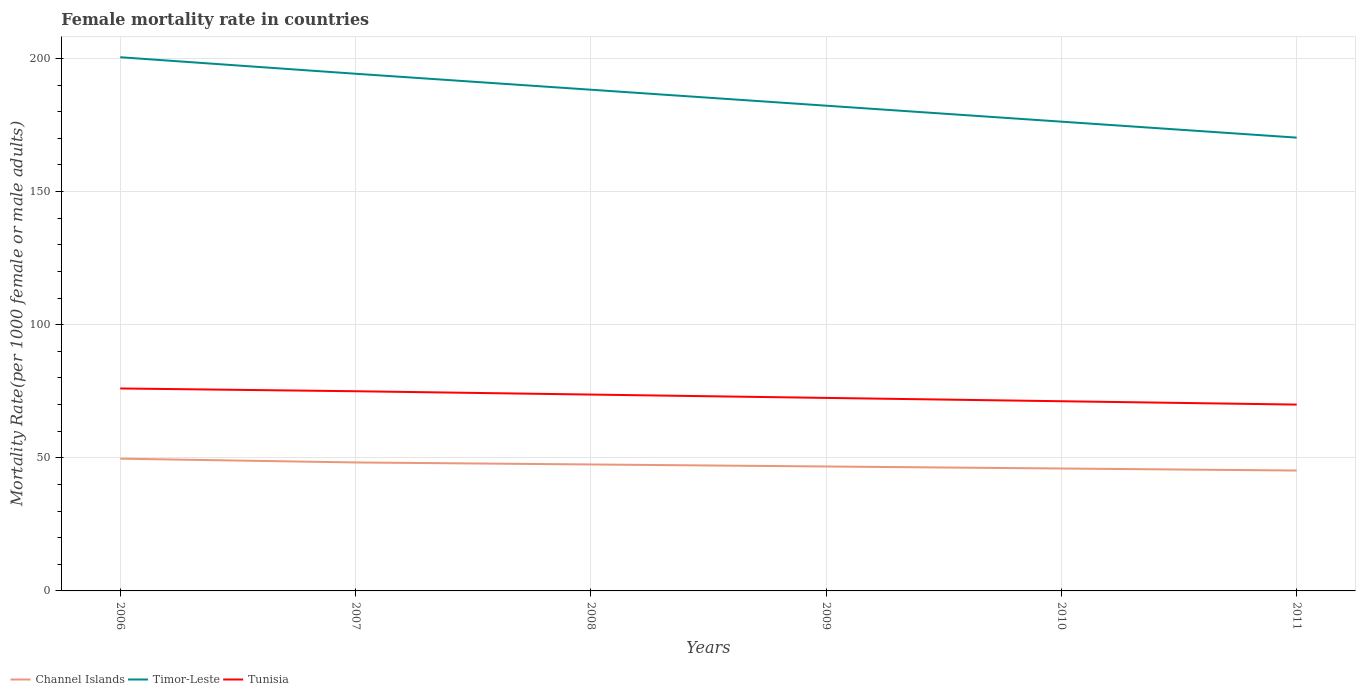Does the line corresponding to Channel Islands intersect with the line corresponding to Timor-Leste?
Give a very brief answer. No. Is the number of lines equal to the number of legend labels?
Offer a terse response. Yes. Across all years, what is the maximum female mortality rate in Tunisia?
Your response must be concise. 70. What is the total female mortality rate in Timor-Leste in the graph?
Give a very brief answer. 12. What is the difference between the highest and the second highest female mortality rate in Channel Islands?
Give a very brief answer. 4.45. What is the difference between the highest and the lowest female mortality rate in Tunisia?
Your answer should be compact. 3. Is the female mortality rate in Channel Islands strictly greater than the female mortality rate in Timor-Leste over the years?
Ensure brevity in your answer.  Yes. How many lines are there?
Give a very brief answer. 3. Does the graph contain any zero values?
Your response must be concise. No. Does the graph contain grids?
Your answer should be compact. Yes. Where does the legend appear in the graph?
Your response must be concise. Bottom left. How are the legend labels stacked?
Offer a terse response. Horizontal. What is the title of the graph?
Give a very brief answer. Female mortality rate in countries. Does "Bahamas" appear as one of the legend labels in the graph?
Give a very brief answer. No. What is the label or title of the X-axis?
Offer a very short reply. Years. What is the label or title of the Y-axis?
Provide a short and direct response. Mortality Rate(per 1000 female or male adults). What is the Mortality Rate(per 1000 female or male adults) of Channel Islands in 2006?
Offer a very short reply. 49.68. What is the Mortality Rate(per 1000 female or male adults) in Timor-Leste in 2006?
Ensure brevity in your answer.  200.48. What is the Mortality Rate(per 1000 female or male adults) of Tunisia in 2006?
Make the answer very short. 76.05. What is the Mortality Rate(per 1000 female or male adults) in Channel Islands in 2007?
Provide a short and direct response. 48.26. What is the Mortality Rate(per 1000 female or male adults) of Timor-Leste in 2007?
Keep it short and to the point. 194.28. What is the Mortality Rate(per 1000 female or male adults) of Tunisia in 2007?
Provide a succinct answer. 75.02. What is the Mortality Rate(per 1000 female or male adults) of Channel Islands in 2008?
Your answer should be compact. 47.5. What is the Mortality Rate(per 1000 female or male adults) in Timor-Leste in 2008?
Keep it short and to the point. 188.28. What is the Mortality Rate(per 1000 female or male adults) of Tunisia in 2008?
Ensure brevity in your answer.  73.76. What is the Mortality Rate(per 1000 female or male adults) in Channel Islands in 2009?
Provide a succinct answer. 46.74. What is the Mortality Rate(per 1000 female or male adults) in Timor-Leste in 2009?
Ensure brevity in your answer.  182.28. What is the Mortality Rate(per 1000 female or male adults) of Tunisia in 2009?
Provide a succinct answer. 72.51. What is the Mortality Rate(per 1000 female or male adults) of Channel Islands in 2010?
Provide a succinct answer. 45.98. What is the Mortality Rate(per 1000 female or male adults) in Timor-Leste in 2010?
Give a very brief answer. 176.28. What is the Mortality Rate(per 1000 female or male adults) in Tunisia in 2010?
Offer a terse response. 71.25. What is the Mortality Rate(per 1000 female or male adults) of Channel Islands in 2011?
Your response must be concise. 45.23. What is the Mortality Rate(per 1000 female or male adults) in Timor-Leste in 2011?
Your answer should be compact. 170.28. What is the Mortality Rate(per 1000 female or male adults) in Tunisia in 2011?
Provide a succinct answer. 70. Across all years, what is the maximum Mortality Rate(per 1000 female or male adults) in Channel Islands?
Offer a terse response. 49.68. Across all years, what is the maximum Mortality Rate(per 1000 female or male adults) in Timor-Leste?
Offer a very short reply. 200.48. Across all years, what is the maximum Mortality Rate(per 1000 female or male adults) of Tunisia?
Provide a short and direct response. 76.05. Across all years, what is the minimum Mortality Rate(per 1000 female or male adults) in Channel Islands?
Give a very brief answer. 45.23. Across all years, what is the minimum Mortality Rate(per 1000 female or male adults) in Timor-Leste?
Ensure brevity in your answer.  170.28. Across all years, what is the minimum Mortality Rate(per 1000 female or male adults) in Tunisia?
Your answer should be compact. 70. What is the total Mortality Rate(per 1000 female or male adults) in Channel Islands in the graph?
Ensure brevity in your answer.  283.4. What is the total Mortality Rate(per 1000 female or male adults) in Timor-Leste in the graph?
Your response must be concise. 1111.89. What is the total Mortality Rate(per 1000 female or male adults) of Tunisia in the graph?
Your answer should be compact. 438.59. What is the difference between the Mortality Rate(per 1000 female or male adults) in Channel Islands in 2006 and that in 2007?
Provide a short and direct response. 1.42. What is the difference between the Mortality Rate(per 1000 female or male adults) of Timor-Leste in 2006 and that in 2007?
Give a very brief answer. 6.2. What is the difference between the Mortality Rate(per 1000 female or male adults) of Tunisia in 2006 and that in 2007?
Keep it short and to the point. 1.03. What is the difference between the Mortality Rate(per 1000 female or male adults) in Channel Islands in 2006 and that in 2008?
Your answer should be very brief. 2.18. What is the difference between the Mortality Rate(per 1000 female or male adults) of Timor-Leste in 2006 and that in 2008?
Your answer should be very brief. 12.2. What is the difference between the Mortality Rate(per 1000 female or male adults) of Tunisia in 2006 and that in 2008?
Your response must be concise. 2.29. What is the difference between the Mortality Rate(per 1000 female or male adults) of Channel Islands in 2006 and that in 2009?
Keep it short and to the point. 2.94. What is the difference between the Mortality Rate(per 1000 female or male adults) of Timor-Leste in 2006 and that in 2009?
Provide a short and direct response. 18.2. What is the difference between the Mortality Rate(per 1000 female or male adults) of Tunisia in 2006 and that in 2009?
Ensure brevity in your answer.  3.54. What is the difference between the Mortality Rate(per 1000 female or male adults) of Channel Islands in 2006 and that in 2010?
Provide a short and direct response. 3.69. What is the difference between the Mortality Rate(per 1000 female or male adults) in Timor-Leste in 2006 and that in 2010?
Your answer should be compact. 24.2. What is the difference between the Mortality Rate(per 1000 female or male adults) in Tunisia in 2006 and that in 2010?
Offer a very short reply. 4.79. What is the difference between the Mortality Rate(per 1000 female or male adults) of Channel Islands in 2006 and that in 2011?
Provide a short and direct response. 4.45. What is the difference between the Mortality Rate(per 1000 female or male adults) of Timor-Leste in 2006 and that in 2011?
Your answer should be very brief. 30.2. What is the difference between the Mortality Rate(per 1000 female or male adults) of Tunisia in 2006 and that in 2011?
Your answer should be very brief. 6.05. What is the difference between the Mortality Rate(per 1000 female or male adults) of Channel Islands in 2007 and that in 2008?
Provide a succinct answer. 0.76. What is the difference between the Mortality Rate(per 1000 female or male adults) of Timor-Leste in 2007 and that in 2008?
Make the answer very short. 6. What is the difference between the Mortality Rate(per 1000 female or male adults) in Tunisia in 2007 and that in 2008?
Keep it short and to the point. 1.25. What is the difference between the Mortality Rate(per 1000 female or male adults) in Channel Islands in 2007 and that in 2009?
Your response must be concise. 1.52. What is the difference between the Mortality Rate(per 1000 female or male adults) in Timor-Leste in 2007 and that in 2009?
Make the answer very short. 12. What is the difference between the Mortality Rate(per 1000 female or male adults) of Tunisia in 2007 and that in 2009?
Give a very brief answer. 2.51. What is the difference between the Mortality Rate(per 1000 female or male adults) in Channel Islands in 2007 and that in 2010?
Your response must be concise. 2.28. What is the difference between the Mortality Rate(per 1000 female or male adults) of Timor-Leste in 2007 and that in 2010?
Your answer should be compact. 18. What is the difference between the Mortality Rate(per 1000 female or male adults) in Tunisia in 2007 and that in 2010?
Your answer should be compact. 3.76. What is the difference between the Mortality Rate(per 1000 female or male adults) of Channel Islands in 2007 and that in 2011?
Give a very brief answer. 3.04. What is the difference between the Mortality Rate(per 1000 female or male adults) in Timor-Leste in 2007 and that in 2011?
Offer a terse response. 24. What is the difference between the Mortality Rate(per 1000 female or male adults) of Tunisia in 2007 and that in 2011?
Provide a short and direct response. 5.01. What is the difference between the Mortality Rate(per 1000 female or male adults) of Channel Islands in 2008 and that in 2009?
Your answer should be very brief. 0.76. What is the difference between the Mortality Rate(per 1000 female or male adults) in Timor-Leste in 2008 and that in 2009?
Your answer should be very brief. 6. What is the difference between the Mortality Rate(per 1000 female or male adults) in Tunisia in 2008 and that in 2009?
Your answer should be very brief. 1.25. What is the difference between the Mortality Rate(per 1000 female or male adults) in Channel Islands in 2008 and that in 2010?
Your response must be concise. 1.52. What is the difference between the Mortality Rate(per 1000 female or male adults) of Timor-Leste in 2008 and that in 2010?
Give a very brief answer. 12. What is the difference between the Mortality Rate(per 1000 female or male adults) in Tunisia in 2008 and that in 2010?
Offer a very short reply. 2.51. What is the difference between the Mortality Rate(per 1000 female or male adults) of Channel Islands in 2008 and that in 2011?
Your answer should be compact. 2.28. What is the difference between the Mortality Rate(per 1000 female or male adults) of Timor-Leste in 2008 and that in 2011?
Provide a succinct answer. 18. What is the difference between the Mortality Rate(per 1000 female or male adults) in Tunisia in 2008 and that in 2011?
Make the answer very short. 3.76. What is the difference between the Mortality Rate(per 1000 female or male adults) of Channel Islands in 2009 and that in 2010?
Keep it short and to the point. 0.76. What is the difference between the Mortality Rate(per 1000 female or male adults) in Timor-Leste in 2009 and that in 2010?
Provide a succinct answer. 6. What is the difference between the Mortality Rate(per 1000 female or male adults) in Tunisia in 2009 and that in 2010?
Make the answer very short. 1.25. What is the difference between the Mortality Rate(per 1000 female or male adults) of Channel Islands in 2009 and that in 2011?
Offer a terse response. 1.52. What is the difference between the Mortality Rate(per 1000 female or male adults) in Timor-Leste in 2009 and that in 2011?
Your response must be concise. 12. What is the difference between the Mortality Rate(per 1000 female or male adults) in Tunisia in 2009 and that in 2011?
Your response must be concise. 2.51. What is the difference between the Mortality Rate(per 1000 female or male adults) in Channel Islands in 2010 and that in 2011?
Your response must be concise. 0.76. What is the difference between the Mortality Rate(per 1000 female or male adults) of Timor-Leste in 2010 and that in 2011?
Your response must be concise. 6. What is the difference between the Mortality Rate(per 1000 female or male adults) of Tunisia in 2010 and that in 2011?
Your answer should be very brief. 1.25. What is the difference between the Mortality Rate(per 1000 female or male adults) in Channel Islands in 2006 and the Mortality Rate(per 1000 female or male adults) in Timor-Leste in 2007?
Provide a succinct answer. -144.6. What is the difference between the Mortality Rate(per 1000 female or male adults) in Channel Islands in 2006 and the Mortality Rate(per 1000 female or male adults) in Tunisia in 2007?
Offer a very short reply. -25.34. What is the difference between the Mortality Rate(per 1000 female or male adults) of Timor-Leste in 2006 and the Mortality Rate(per 1000 female or male adults) of Tunisia in 2007?
Your answer should be very brief. 125.46. What is the difference between the Mortality Rate(per 1000 female or male adults) in Channel Islands in 2006 and the Mortality Rate(per 1000 female or male adults) in Timor-Leste in 2008?
Make the answer very short. -138.6. What is the difference between the Mortality Rate(per 1000 female or male adults) in Channel Islands in 2006 and the Mortality Rate(per 1000 female or male adults) in Tunisia in 2008?
Your answer should be very brief. -24.08. What is the difference between the Mortality Rate(per 1000 female or male adults) of Timor-Leste in 2006 and the Mortality Rate(per 1000 female or male adults) of Tunisia in 2008?
Provide a succinct answer. 126.72. What is the difference between the Mortality Rate(per 1000 female or male adults) of Channel Islands in 2006 and the Mortality Rate(per 1000 female or male adults) of Timor-Leste in 2009?
Provide a short and direct response. -132.6. What is the difference between the Mortality Rate(per 1000 female or male adults) in Channel Islands in 2006 and the Mortality Rate(per 1000 female or male adults) in Tunisia in 2009?
Ensure brevity in your answer.  -22.83. What is the difference between the Mortality Rate(per 1000 female or male adults) of Timor-Leste in 2006 and the Mortality Rate(per 1000 female or male adults) of Tunisia in 2009?
Give a very brief answer. 127.97. What is the difference between the Mortality Rate(per 1000 female or male adults) in Channel Islands in 2006 and the Mortality Rate(per 1000 female or male adults) in Timor-Leste in 2010?
Ensure brevity in your answer.  -126.6. What is the difference between the Mortality Rate(per 1000 female or male adults) of Channel Islands in 2006 and the Mortality Rate(per 1000 female or male adults) of Tunisia in 2010?
Your answer should be compact. -21.57. What is the difference between the Mortality Rate(per 1000 female or male adults) in Timor-Leste in 2006 and the Mortality Rate(per 1000 female or male adults) in Tunisia in 2010?
Provide a short and direct response. 129.22. What is the difference between the Mortality Rate(per 1000 female or male adults) of Channel Islands in 2006 and the Mortality Rate(per 1000 female or male adults) of Timor-Leste in 2011?
Give a very brief answer. -120.6. What is the difference between the Mortality Rate(per 1000 female or male adults) of Channel Islands in 2006 and the Mortality Rate(per 1000 female or male adults) of Tunisia in 2011?
Offer a very short reply. -20.32. What is the difference between the Mortality Rate(per 1000 female or male adults) in Timor-Leste in 2006 and the Mortality Rate(per 1000 female or male adults) in Tunisia in 2011?
Make the answer very short. 130.48. What is the difference between the Mortality Rate(per 1000 female or male adults) of Channel Islands in 2007 and the Mortality Rate(per 1000 female or male adults) of Timor-Leste in 2008?
Ensure brevity in your answer.  -140.02. What is the difference between the Mortality Rate(per 1000 female or male adults) in Channel Islands in 2007 and the Mortality Rate(per 1000 female or male adults) in Tunisia in 2008?
Offer a terse response. -25.5. What is the difference between the Mortality Rate(per 1000 female or male adults) of Timor-Leste in 2007 and the Mortality Rate(per 1000 female or male adults) of Tunisia in 2008?
Give a very brief answer. 120.52. What is the difference between the Mortality Rate(per 1000 female or male adults) of Channel Islands in 2007 and the Mortality Rate(per 1000 female or male adults) of Timor-Leste in 2009?
Your answer should be compact. -134.02. What is the difference between the Mortality Rate(per 1000 female or male adults) of Channel Islands in 2007 and the Mortality Rate(per 1000 female or male adults) of Tunisia in 2009?
Provide a short and direct response. -24.25. What is the difference between the Mortality Rate(per 1000 female or male adults) in Timor-Leste in 2007 and the Mortality Rate(per 1000 female or male adults) in Tunisia in 2009?
Offer a terse response. 121.77. What is the difference between the Mortality Rate(per 1000 female or male adults) of Channel Islands in 2007 and the Mortality Rate(per 1000 female or male adults) of Timor-Leste in 2010?
Make the answer very short. -128.02. What is the difference between the Mortality Rate(per 1000 female or male adults) of Channel Islands in 2007 and the Mortality Rate(per 1000 female or male adults) of Tunisia in 2010?
Make the answer very short. -22.99. What is the difference between the Mortality Rate(per 1000 female or male adults) of Timor-Leste in 2007 and the Mortality Rate(per 1000 female or male adults) of Tunisia in 2010?
Your response must be concise. 123.03. What is the difference between the Mortality Rate(per 1000 female or male adults) of Channel Islands in 2007 and the Mortality Rate(per 1000 female or male adults) of Timor-Leste in 2011?
Your answer should be very brief. -122.02. What is the difference between the Mortality Rate(per 1000 female or male adults) of Channel Islands in 2007 and the Mortality Rate(per 1000 female or male adults) of Tunisia in 2011?
Keep it short and to the point. -21.74. What is the difference between the Mortality Rate(per 1000 female or male adults) in Timor-Leste in 2007 and the Mortality Rate(per 1000 female or male adults) in Tunisia in 2011?
Ensure brevity in your answer.  124.28. What is the difference between the Mortality Rate(per 1000 female or male adults) in Channel Islands in 2008 and the Mortality Rate(per 1000 female or male adults) in Timor-Leste in 2009?
Offer a terse response. -134.78. What is the difference between the Mortality Rate(per 1000 female or male adults) of Channel Islands in 2008 and the Mortality Rate(per 1000 female or male adults) of Tunisia in 2009?
Provide a short and direct response. -25.01. What is the difference between the Mortality Rate(per 1000 female or male adults) in Timor-Leste in 2008 and the Mortality Rate(per 1000 female or male adults) in Tunisia in 2009?
Offer a very short reply. 115.77. What is the difference between the Mortality Rate(per 1000 female or male adults) of Channel Islands in 2008 and the Mortality Rate(per 1000 female or male adults) of Timor-Leste in 2010?
Provide a succinct answer. -128.78. What is the difference between the Mortality Rate(per 1000 female or male adults) of Channel Islands in 2008 and the Mortality Rate(per 1000 female or male adults) of Tunisia in 2010?
Offer a very short reply. -23.75. What is the difference between the Mortality Rate(per 1000 female or male adults) in Timor-Leste in 2008 and the Mortality Rate(per 1000 female or male adults) in Tunisia in 2010?
Provide a short and direct response. 117.03. What is the difference between the Mortality Rate(per 1000 female or male adults) in Channel Islands in 2008 and the Mortality Rate(per 1000 female or male adults) in Timor-Leste in 2011?
Offer a very short reply. -122.78. What is the difference between the Mortality Rate(per 1000 female or male adults) of Channel Islands in 2008 and the Mortality Rate(per 1000 female or male adults) of Tunisia in 2011?
Keep it short and to the point. -22.5. What is the difference between the Mortality Rate(per 1000 female or male adults) of Timor-Leste in 2008 and the Mortality Rate(per 1000 female or male adults) of Tunisia in 2011?
Keep it short and to the point. 118.28. What is the difference between the Mortality Rate(per 1000 female or male adults) in Channel Islands in 2009 and the Mortality Rate(per 1000 female or male adults) in Timor-Leste in 2010?
Make the answer very short. -129.54. What is the difference between the Mortality Rate(per 1000 female or male adults) in Channel Islands in 2009 and the Mortality Rate(per 1000 female or male adults) in Tunisia in 2010?
Keep it short and to the point. -24.51. What is the difference between the Mortality Rate(per 1000 female or male adults) of Timor-Leste in 2009 and the Mortality Rate(per 1000 female or male adults) of Tunisia in 2010?
Provide a short and direct response. 111.03. What is the difference between the Mortality Rate(per 1000 female or male adults) in Channel Islands in 2009 and the Mortality Rate(per 1000 female or male adults) in Timor-Leste in 2011?
Offer a terse response. -123.54. What is the difference between the Mortality Rate(per 1000 female or male adults) in Channel Islands in 2009 and the Mortality Rate(per 1000 female or male adults) in Tunisia in 2011?
Your answer should be compact. -23.26. What is the difference between the Mortality Rate(per 1000 female or male adults) of Timor-Leste in 2009 and the Mortality Rate(per 1000 female or male adults) of Tunisia in 2011?
Offer a very short reply. 112.28. What is the difference between the Mortality Rate(per 1000 female or male adults) of Channel Islands in 2010 and the Mortality Rate(per 1000 female or male adults) of Timor-Leste in 2011?
Offer a very short reply. -124.3. What is the difference between the Mortality Rate(per 1000 female or male adults) of Channel Islands in 2010 and the Mortality Rate(per 1000 female or male adults) of Tunisia in 2011?
Ensure brevity in your answer.  -24.02. What is the difference between the Mortality Rate(per 1000 female or male adults) in Timor-Leste in 2010 and the Mortality Rate(per 1000 female or male adults) in Tunisia in 2011?
Give a very brief answer. 106.28. What is the average Mortality Rate(per 1000 female or male adults) in Channel Islands per year?
Keep it short and to the point. 47.23. What is the average Mortality Rate(per 1000 female or male adults) in Timor-Leste per year?
Make the answer very short. 185.31. What is the average Mortality Rate(per 1000 female or male adults) in Tunisia per year?
Provide a short and direct response. 73.1. In the year 2006, what is the difference between the Mortality Rate(per 1000 female or male adults) of Channel Islands and Mortality Rate(per 1000 female or male adults) of Timor-Leste?
Provide a short and direct response. -150.8. In the year 2006, what is the difference between the Mortality Rate(per 1000 female or male adults) in Channel Islands and Mortality Rate(per 1000 female or male adults) in Tunisia?
Your answer should be compact. -26.37. In the year 2006, what is the difference between the Mortality Rate(per 1000 female or male adults) in Timor-Leste and Mortality Rate(per 1000 female or male adults) in Tunisia?
Offer a terse response. 124.43. In the year 2007, what is the difference between the Mortality Rate(per 1000 female or male adults) in Channel Islands and Mortality Rate(per 1000 female or male adults) in Timor-Leste?
Offer a terse response. -146.02. In the year 2007, what is the difference between the Mortality Rate(per 1000 female or male adults) in Channel Islands and Mortality Rate(per 1000 female or male adults) in Tunisia?
Provide a succinct answer. -26.75. In the year 2007, what is the difference between the Mortality Rate(per 1000 female or male adults) of Timor-Leste and Mortality Rate(per 1000 female or male adults) of Tunisia?
Your response must be concise. 119.27. In the year 2008, what is the difference between the Mortality Rate(per 1000 female or male adults) of Channel Islands and Mortality Rate(per 1000 female or male adults) of Timor-Leste?
Your answer should be very brief. -140.78. In the year 2008, what is the difference between the Mortality Rate(per 1000 female or male adults) of Channel Islands and Mortality Rate(per 1000 female or male adults) of Tunisia?
Offer a very short reply. -26.26. In the year 2008, what is the difference between the Mortality Rate(per 1000 female or male adults) in Timor-Leste and Mortality Rate(per 1000 female or male adults) in Tunisia?
Keep it short and to the point. 114.52. In the year 2009, what is the difference between the Mortality Rate(per 1000 female or male adults) of Channel Islands and Mortality Rate(per 1000 female or male adults) of Timor-Leste?
Ensure brevity in your answer.  -135.54. In the year 2009, what is the difference between the Mortality Rate(per 1000 female or male adults) in Channel Islands and Mortality Rate(per 1000 female or male adults) in Tunisia?
Your answer should be compact. -25.76. In the year 2009, what is the difference between the Mortality Rate(per 1000 female or male adults) in Timor-Leste and Mortality Rate(per 1000 female or male adults) in Tunisia?
Make the answer very short. 109.77. In the year 2010, what is the difference between the Mortality Rate(per 1000 female or male adults) in Channel Islands and Mortality Rate(per 1000 female or male adults) in Timor-Leste?
Ensure brevity in your answer.  -130.3. In the year 2010, what is the difference between the Mortality Rate(per 1000 female or male adults) in Channel Islands and Mortality Rate(per 1000 female or male adults) in Tunisia?
Your answer should be compact. -25.27. In the year 2010, what is the difference between the Mortality Rate(per 1000 female or male adults) in Timor-Leste and Mortality Rate(per 1000 female or male adults) in Tunisia?
Your answer should be very brief. 105.03. In the year 2011, what is the difference between the Mortality Rate(per 1000 female or male adults) in Channel Islands and Mortality Rate(per 1000 female or male adults) in Timor-Leste?
Your answer should be compact. -125.06. In the year 2011, what is the difference between the Mortality Rate(per 1000 female or male adults) in Channel Islands and Mortality Rate(per 1000 female or male adults) in Tunisia?
Make the answer very short. -24.77. In the year 2011, what is the difference between the Mortality Rate(per 1000 female or male adults) in Timor-Leste and Mortality Rate(per 1000 female or male adults) in Tunisia?
Your answer should be very brief. 100.28. What is the ratio of the Mortality Rate(per 1000 female or male adults) in Channel Islands in 2006 to that in 2007?
Offer a terse response. 1.03. What is the ratio of the Mortality Rate(per 1000 female or male adults) in Timor-Leste in 2006 to that in 2007?
Your answer should be very brief. 1.03. What is the ratio of the Mortality Rate(per 1000 female or male adults) in Tunisia in 2006 to that in 2007?
Offer a very short reply. 1.01. What is the ratio of the Mortality Rate(per 1000 female or male adults) of Channel Islands in 2006 to that in 2008?
Provide a short and direct response. 1.05. What is the ratio of the Mortality Rate(per 1000 female or male adults) of Timor-Leste in 2006 to that in 2008?
Provide a short and direct response. 1.06. What is the ratio of the Mortality Rate(per 1000 female or male adults) of Tunisia in 2006 to that in 2008?
Your answer should be compact. 1.03. What is the ratio of the Mortality Rate(per 1000 female or male adults) in Channel Islands in 2006 to that in 2009?
Offer a terse response. 1.06. What is the ratio of the Mortality Rate(per 1000 female or male adults) in Timor-Leste in 2006 to that in 2009?
Your answer should be compact. 1.1. What is the ratio of the Mortality Rate(per 1000 female or male adults) in Tunisia in 2006 to that in 2009?
Your answer should be very brief. 1.05. What is the ratio of the Mortality Rate(per 1000 female or male adults) of Channel Islands in 2006 to that in 2010?
Your answer should be compact. 1.08. What is the ratio of the Mortality Rate(per 1000 female or male adults) in Timor-Leste in 2006 to that in 2010?
Give a very brief answer. 1.14. What is the ratio of the Mortality Rate(per 1000 female or male adults) in Tunisia in 2006 to that in 2010?
Your answer should be compact. 1.07. What is the ratio of the Mortality Rate(per 1000 female or male adults) of Channel Islands in 2006 to that in 2011?
Your response must be concise. 1.1. What is the ratio of the Mortality Rate(per 1000 female or male adults) of Timor-Leste in 2006 to that in 2011?
Ensure brevity in your answer.  1.18. What is the ratio of the Mortality Rate(per 1000 female or male adults) in Tunisia in 2006 to that in 2011?
Provide a succinct answer. 1.09. What is the ratio of the Mortality Rate(per 1000 female or male adults) of Timor-Leste in 2007 to that in 2008?
Make the answer very short. 1.03. What is the ratio of the Mortality Rate(per 1000 female or male adults) of Channel Islands in 2007 to that in 2009?
Your answer should be compact. 1.03. What is the ratio of the Mortality Rate(per 1000 female or male adults) of Timor-Leste in 2007 to that in 2009?
Your answer should be very brief. 1.07. What is the ratio of the Mortality Rate(per 1000 female or male adults) of Tunisia in 2007 to that in 2009?
Your response must be concise. 1.03. What is the ratio of the Mortality Rate(per 1000 female or male adults) of Channel Islands in 2007 to that in 2010?
Offer a very short reply. 1.05. What is the ratio of the Mortality Rate(per 1000 female or male adults) in Timor-Leste in 2007 to that in 2010?
Ensure brevity in your answer.  1.1. What is the ratio of the Mortality Rate(per 1000 female or male adults) of Tunisia in 2007 to that in 2010?
Make the answer very short. 1.05. What is the ratio of the Mortality Rate(per 1000 female or male adults) of Channel Islands in 2007 to that in 2011?
Make the answer very short. 1.07. What is the ratio of the Mortality Rate(per 1000 female or male adults) of Timor-Leste in 2007 to that in 2011?
Keep it short and to the point. 1.14. What is the ratio of the Mortality Rate(per 1000 female or male adults) of Tunisia in 2007 to that in 2011?
Provide a succinct answer. 1.07. What is the ratio of the Mortality Rate(per 1000 female or male adults) of Channel Islands in 2008 to that in 2009?
Make the answer very short. 1.02. What is the ratio of the Mortality Rate(per 1000 female or male adults) in Timor-Leste in 2008 to that in 2009?
Keep it short and to the point. 1.03. What is the ratio of the Mortality Rate(per 1000 female or male adults) in Tunisia in 2008 to that in 2009?
Give a very brief answer. 1.02. What is the ratio of the Mortality Rate(per 1000 female or male adults) of Channel Islands in 2008 to that in 2010?
Make the answer very short. 1.03. What is the ratio of the Mortality Rate(per 1000 female or male adults) in Timor-Leste in 2008 to that in 2010?
Offer a very short reply. 1.07. What is the ratio of the Mortality Rate(per 1000 female or male adults) of Tunisia in 2008 to that in 2010?
Give a very brief answer. 1.04. What is the ratio of the Mortality Rate(per 1000 female or male adults) of Channel Islands in 2008 to that in 2011?
Give a very brief answer. 1.05. What is the ratio of the Mortality Rate(per 1000 female or male adults) of Timor-Leste in 2008 to that in 2011?
Give a very brief answer. 1.11. What is the ratio of the Mortality Rate(per 1000 female or male adults) in Tunisia in 2008 to that in 2011?
Your answer should be very brief. 1.05. What is the ratio of the Mortality Rate(per 1000 female or male adults) in Channel Islands in 2009 to that in 2010?
Offer a terse response. 1.02. What is the ratio of the Mortality Rate(per 1000 female or male adults) in Timor-Leste in 2009 to that in 2010?
Your response must be concise. 1.03. What is the ratio of the Mortality Rate(per 1000 female or male adults) in Tunisia in 2009 to that in 2010?
Offer a terse response. 1.02. What is the ratio of the Mortality Rate(per 1000 female or male adults) of Channel Islands in 2009 to that in 2011?
Ensure brevity in your answer.  1.03. What is the ratio of the Mortality Rate(per 1000 female or male adults) in Timor-Leste in 2009 to that in 2011?
Your answer should be very brief. 1.07. What is the ratio of the Mortality Rate(per 1000 female or male adults) of Tunisia in 2009 to that in 2011?
Provide a succinct answer. 1.04. What is the ratio of the Mortality Rate(per 1000 female or male adults) in Channel Islands in 2010 to that in 2011?
Offer a terse response. 1.02. What is the ratio of the Mortality Rate(per 1000 female or male adults) of Timor-Leste in 2010 to that in 2011?
Give a very brief answer. 1.04. What is the ratio of the Mortality Rate(per 1000 female or male adults) of Tunisia in 2010 to that in 2011?
Offer a very short reply. 1.02. What is the difference between the highest and the second highest Mortality Rate(per 1000 female or male adults) of Channel Islands?
Provide a short and direct response. 1.42. What is the difference between the highest and the second highest Mortality Rate(per 1000 female or male adults) of Timor-Leste?
Provide a short and direct response. 6.2. What is the difference between the highest and the second highest Mortality Rate(per 1000 female or male adults) in Tunisia?
Ensure brevity in your answer.  1.03. What is the difference between the highest and the lowest Mortality Rate(per 1000 female or male adults) in Channel Islands?
Make the answer very short. 4.45. What is the difference between the highest and the lowest Mortality Rate(per 1000 female or male adults) in Timor-Leste?
Give a very brief answer. 30.2. What is the difference between the highest and the lowest Mortality Rate(per 1000 female or male adults) of Tunisia?
Ensure brevity in your answer.  6.05. 